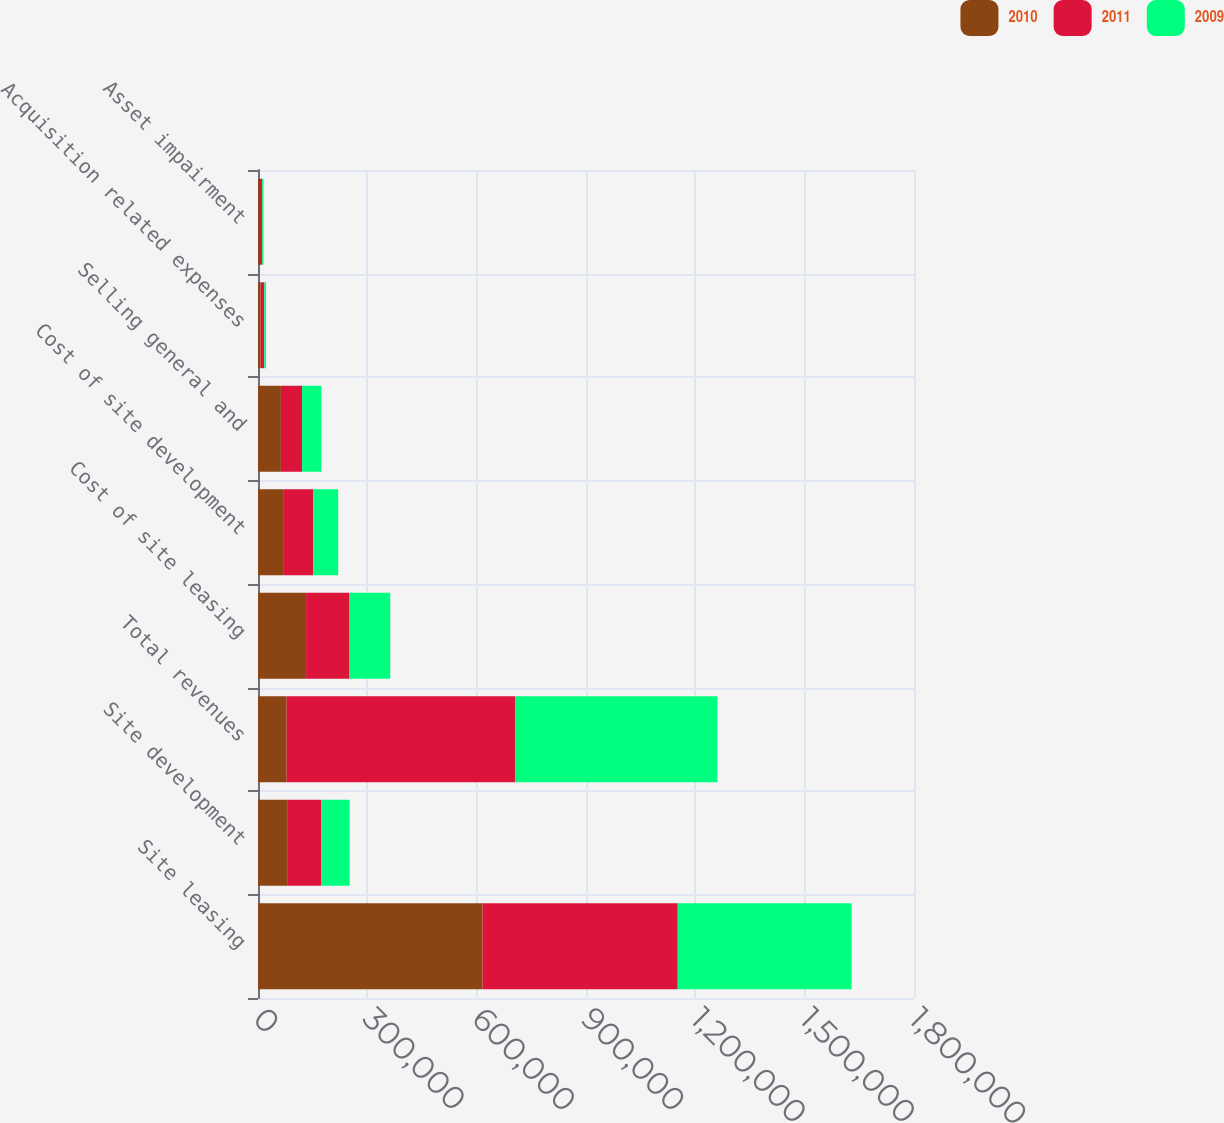Convert chart to OTSL. <chart><loc_0><loc_0><loc_500><loc_500><stacked_bar_chart><ecel><fcel>Site leasing<fcel>Site development<fcel>Total revenues<fcel>Cost of site leasing<fcel>Cost of site development<fcel>Selling general and<fcel>Acquisition related expenses<fcel>Asset impairment<nl><fcel>2010<fcel>616294<fcel>81876<fcel>78506<fcel>131916<fcel>71005<fcel>62828<fcel>7144<fcel>5472<nl><fcel>2011<fcel>535444<fcel>91175<fcel>626619<fcel>119141<fcel>80301<fcel>58209<fcel>10106<fcel>5862<nl><fcel>2009<fcel>477007<fcel>78506<fcel>555513<fcel>111842<fcel>68701<fcel>52785<fcel>4810<fcel>3884<nl></chart> 